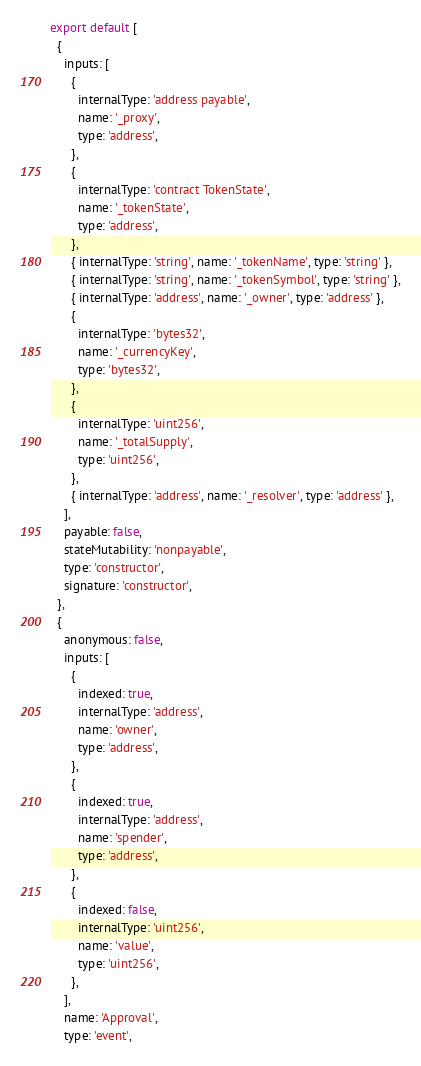Convert code to text. <code><loc_0><loc_0><loc_500><loc_500><_JavaScript_>export default [
  {
    inputs: [
      {
        internalType: 'address payable',
        name: '_proxy',
        type: 'address',
      },
      {
        internalType: 'contract TokenState',
        name: '_tokenState',
        type: 'address',
      },
      { internalType: 'string', name: '_tokenName', type: 'string' },
      { internalType: 'string', name: '_tokenSymbol', type: 'string' },
      { internalType: 'address', name: '_owner', type: 'address' },
      {
        internalType: 'bytes32',
        name: '_currencyKey',
        type: 'bytes32',
      },
      {
        internalType: 'uint256',
        name: '_totalSupply',
        type: 'uint256',
      },
      { internalType: 'address', name: '_resolver', type: 'address' },
    ],
    payable: false,
    stateMutability: 'nonpayable',
    type: 'constructor',
    signature: 'constructor',
  },
  {
    anonymous: false,
    inputs: [
      {
        indexed: true,
        internalType: 'address',
        name: 'owner',
        type: 'address',
      },
      {
        indexed: true,
        internalType: 'address',
        name: 'spender',
        type: 'address',
      },
      {
        indexed: false,
        internalType: 'uint256',
        name: 'value',
        type: 'uint256',
      },
    ],
    name: 'Approval',
    type: 'event',</code> 